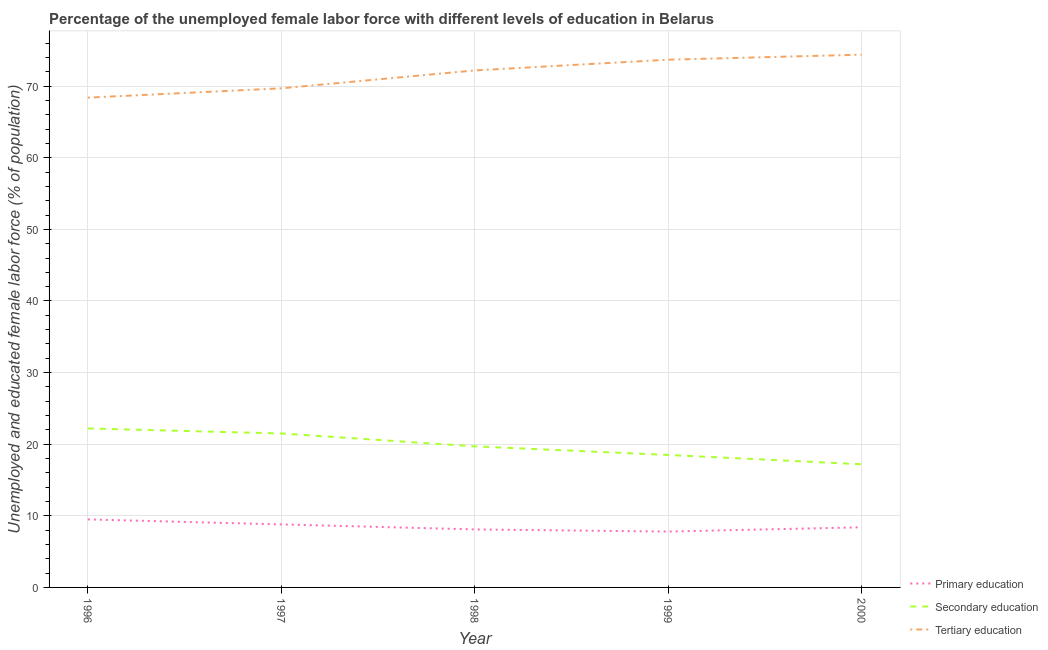Does the line corresponding to percentage of female labor force who received tertiary education intersect with the line corresponding to percentage of female labor force who received secondary education?
Provide a short and direct response. No. Is the number of lines equal to the number of legend labels?
Ensure brevity in your answer.  Yes. What is the percentage of female labor force who received tertiary education in 1999?
Offer a terse response. 73.7. Across all years, what is the maximum percentage of female labor force who received secondary education?
Ensure brevity in your answer.  22.2. Across all years, what is the minimum percentage of female labor force who received secondary education?
Provide a short and direct response. 17.2. What is the total percentage of female labor force who received primary education in the graph?
Provide a short and direct response. 42.6. What is the difference between the percentage of female labor force who received tertiary education in 1996 and that in 2000?
Make the answer very short. -6. What is the difference between the percentage of female labor force who received tertiary education in 1999 and the percentage of female labor force who received secondary education in 1998?
Your answer should be very brief. 54. What is the average percentage of female labor force who received tertiary education per year?
Your answer should be very brief. 71.68. In the year 2000, what is the difference between the percentage of female labor force who received primary education and percentage of female labor force who received tertiary education?
Your response must be concise. -66. What is the ratio of the percentage of female labor force who received secondary education in 1997 to that in 2000?
Keep it short and to the point. 1.25. What is the difference between the highest and the second highest percentage of female labor force who received primary education?
Your answer should be compact. 0.7. What is the difference between the highest and the lowest percentage of female labor force who received tertiary education?
Ensure brevity in your answer.  6. In how many years, is the percentage of female labor force who received tertiary education greater than the average percentage of female labor force who received tertiary education taken over all years?
Give a very brief answer. 3. Is the sum of the percentage of female labor force who received primary education in 1996 and 1999 greater than the maximum percentage of female labor force who received secondary education across all years?
Offer a very short reply. No. Is the percentage of female labor force who received tertiary education strictly greater than the percentage of female labor force who received primary education over the years?
Offer a very short reply. Yes. Does the graph contain grids?
Offer a very short reply. Yes. Where does the legend appear in the graph?
Offer a very short reply. Bottom right. How many legend labels are there?
Your answer should be compact. 3. What is the title of the graph?
Offer a terse response. Percentage of the unemployed female labor force with different levels of education in Belarus. What is the label or title of the X-axis?
Provide a short and direct response. Year. What is the label or title of the Y-axis?
Make the answer very short. Unemployed and educated female labor force (% of population). What is the Unemployed and educated female labor force (% of population) in Secondary education in 1996?
Offer a terse response. 22.2. What is the Unemployed and educated female labor force (% of population) of Tertiary education in 1996?
Your response must be concise. 68.4. What is the Unemployed and educated female labor force (% of population) of Primary education in 1997?
Provide a succinct answer. 8.8. What is the Unemployed and educated female labor force (% of population) of Tertiary education in 1997?
Give a very brief answer. 69.7. What is the Unemployed and educated female labor force (% of population) of Primary education in 1998?
Offer a very short reply. 8.1. What is the Unemployed and educated female labor force (% of population) of Secondary education in 1998?
Offer a very short reply. 19.7. What is the Unemployed and educated female labor force (% of population) of Tertiary education in 1998?
Your answer should be very brief. 72.2. What is the Unemployed and educated female labor force (% of population) in Primary education in 1999?
Offer a terse response. 7.8. What is the Unemployed and educated female labor force (% of population) in Secondary education in 1999?
Make the answer very short. 18.5. What is the Unemployed and educated female labor force (% of population) of Tertiary education in 1999?
Provide a short and direct response. 73.7. What is the Unemployed and educated female labor force (% of population) in Primary education in 2000?
Give a very brief answer. 8.4. What is the Unemployed and educated female labor force (% of population) in Secondary education in 2000?
Ensure brevity in your answer.  17.2. What is the Unemployed and educated female labor force (% of population) in Tertiary education in 2000?
Provide a short and direct response. 74.4. Across all years, what is the maximum Unemployed and educated female labor force (% of population) of Primary education?
Make the answer very short. 9.5. Across all years, what is the maximum Unemployed and educated female labor force (% of population) of Secondary education?
Ensure brevity in your answer.  22.2. Across all years, what is the maximum Unemployed and educated female labor force (% of population) in Tertiary education?
Your answer should be compact. 74.4. Across all years, what is the minimum Unemployed and educated female labor force (% of population) in Primary education?
Offer a terse response. 7.8. Across all years, what is the minimum Unemployed and educated female labor force (% of population) in Secondary education?
Your answer should be compact. 17.2. Across all years, what is the minimum Unemployed and educated female labor force (% of population) in Tertiary education?
Give a very brief answer. 68.4. What is the total Unemployed and educated female labor force (% of population) in Primary education in the graph?
Provide a succinct answer. 42.6. What is the total Unemployed and educated female labor force (% of population) of Secondary education in the graph?
Ensure brevity in your answer.  99.1. What is the total Unemployed and educated female labor force (% of population) of Tertiary education in the graph?
Provide a succinct answer. 358.4. What is the difference between the Unemployed and educated female labor force (% of population) in Secondary education in 1996 and that in 1997?
Keep it short and to the point. 0.7. What is the difference between the Unemployed and educated female labor force (% of population) in Secondary education in 1996 and that in 1998?
Offer a terse response. 2.5. What is the difference between the Unemployed and educated female labor force (% of population) in Tertiary education in 1996 and that in 1998?
Give a very brief answer. -3.8. What is the difference between the Unemployed and educated female labor force (% of population) in Primary education in 1996 and that in 2000?
Keep it short and to the point. 1.1. What is the difference between the Unemployed and educated female labor force (% of population) of Tertiary education in 1996 and that in 2000?
Make the answer very short. -6. What is the difference between the Unemployed and educated female labor force (% of population) in Primary education in 1997 and that in 1998?
Give a very brief answer. 0.7. What is the difference between the Unemployed and educated female labor force (% of population) of Tertiary education in 1998 and that in 2000?
Your answer should be compact. -2.2. What is the difference between the Unemployed and educated female labor force (% of population) of Secondary education in 1999 and that in 2000?
Keep it short and to the point. 1.3. What is the difference between the Unemployed and educated female labor force (% of population) of Primary education in 1996 and the Unemployed and educated female labor force (% of population) of Secondary education in 1997?
Offer a terse response. -12. What is the difference between the Unemployed and educated female labor force (% of population) of Primary education in 1996 and the Unemployed and educated female labor force (% of population) of Tertiary education in 1997?
Your answer should be compact. -60.2. What is the difference between the Unemployed and educated female labor force (% of population) of Secondary education in 1996 and the Unemployed and educated female labor force (% of population) of Tertiary education in 1997?
Ensure brevity in your answer.  -47.5. What is the difference between the Unemployed and educated female labor force (% of population) of Primary education in 1996 and the Unemployed and educated female labor force (% of population) of Secondary education in 1998?
Give a very brief answer. -10.2. What is the difference between the Unemployed and educated female labor force (% of population) in Primary education in 1996 and the Unemployed and educated female labor force (% of population) in Tertiary education in 1998?
Make the answer very short. -62.7. What is the difference between the Unemployed and educated female labor force (% of population) of Primary education in 1996 and the Unemployed and educated female labor force (% of population) of Tertiary education in 1999?
Ensure brevity in your answer.  -64.2. What is the difference between the Unemployed and educated female labor force (% of population) of Secondary education in 1996 and the Unemployed and educated female labor force (% of population) of Tertiary education in 1999?
Provide a short and direct response. -51.5. What is the difference between the Unemployed and educated female labor force (% of population) of Primary education in 1996 and the Unemployed and educated female labor force (% of population) of Secondary education in 2000?
Your answer should be compact. -7.7. What is the difference between the Unemployed and educated female labor force (% of population) of Primary education in 1996 and the Unemployed and educated female labor force (% of population) of Tertiary education in 2000?
Your answer should be compact. -64.9. What is the difference between the Unemployed and educated female labor force (% of population) in Secondary education in 1996 and the Unemployed and educated female labor force (% of population) in Tertiary education in 2000?
Offer a terse response. -52.2. What is the difference between the Unemployed and educated female labor force (% of population) in Primary education in 1997 and the Unemployed and educated female labor force (% of population) in Secondary education in 1998?
Your response must be concise. -10.9. What is the difference between the Unemployed and educated female labor force (% of population) in Primary education in 1997 and the Unemployed and educated female labor force (% of population) in Tertiary education in 1998?
Your answer should be very brief. -63.4. What is the difference between the Unemployed and educated female labor force (% of population) of Secondary education in 1997 and the Unemployed and educated female labor force (% of population) of Tertiary education in 1998?
Make the answer very short. -50.7. What is the difference between the Unemployed and educated female labor force (% of population) in Primary education in 1997 and the Unemployed and educated female labor force (% of population) in Tertiary education in 1999?
Provide a succinct answer. -64.9. What is the difference between the Unemployed and educated female labor force (% of population) in Secondary education in 1997 and the Unemployed and educated female labor force (% of population) in Tertiary education in 1999?
Your response must be concise. -52.2. What is the difference between the Unemployed and educated female labor force (% of population) of Primary education in 1997 and the Unemployed and educated female labor force (% of population) of Secondary education in 2000?
Give a very brief answer. -8.4. What is the difference between the Unemployed and educated female labor force (% of population) in Primary education in 1997 and the Unemployed and educated female labor force (% of population) in Tertiary education in 2000?
Ensure brevity in your answer.  -65.6. What is the difference between the Unemployed and educated female labor force (% of population) of Secondary education in 1997 and the Unemployed and educated female labor force (% of population) of Tertiary education in 2000?
Offer a terse response. -52.9. What is the difference between the Unemployed and educated female labor force (% of population) of Primary education in 1998 and the Unemployed and educated female labor force (% of population) of Tertiary education in 1999?
Your answer should be very brief. -65.6. What is the difference between the Unemployed and educated female labor force (% of population) in Secondary education in 1998 and the Unemployed and educated female labor force (% of population) in Tertiary education in 1999?
Offer a terse response. -54. What is the difference between the Unemployed and educated female labor force (% of population) of Primary education in 1998 and the Unemployed and educated female labor force (% of population) of Secondary education in 2000?
Your response must be concise. -9.1. What is the difference between the Unemployed and educated female labor force (% of population) in Primary education in 1998 and the Unemployed and educated female labor force (% of population) in Tertiary education in 2000?
Your response must be concise. -66.3. What is the difference between the Unemployed and educated female labor force (% of population) in Secondary education in 1998 and the Unemployed and educated female labor force (% of population) in Tertiary education in 2000?
Offer a terse response. -54.7. What is the difference between the Unemployed and educated female labor force (% of population) in Primary education in 1999 and the Unemployed and educated female labor force (% of population) in Secondary education in 2000?
Your response must be concise. -9.4. What is the difference between the Unemployed and educated female labor force (% of population) in Primary education in 1999 and the Unemployed and educated female labor force (% of population) in Tertiary education in 2000?
Make the answer very short. -66.6. What is the difference between the Unemployed and educated female labor force (% of population) of Secondary education in 1999 and the Unemployed and educated female labor force (% of population) of Tertiary education in 2000?
Provide a succinct answer. -55.9. What is the average Unemployed and educated female labor force (% of population) in Primary education per year?
Your answer should be compact. 8.52. What is the average Unemployed and educated female labor force (% of population) of Secondary education per year?
Make the answer very short. 19.82. What is the average Unemployed and educated female labor force (% of population) of Tertiary education per year?
Give a very brief answer. 71.68. In the year 1996, what is the difference between the Unemployed and educated female labor force (% of population) of Primary education and Unemployed and educated female labor force (% of population) of Secondary education?
Provide a short and direct response. -12.7. In the year 1996, what is the difference between the Unemployed and educated female labor force (% of population) of Primary education and Unemployed and educated female labor force (% of population) of Tertiary education?
Your response must be concise. -58.9. In the year 1996, what is the difference between the Unemployed and educated female labor force (% of population) in Secondary education and Unemployed and educated female labor force (% of population) in Tertiary education?
Keep it short and to the point. -46.2. In the year 1997, what is the difference between the Unemployed and educated female labor force (% of population) in Primary education and Unemployed and educated female labor force (% of population) in Secondary education?
Provide a short and direct response. -12.7. In the year 1997, what is the difference between the Unemployed and educated female labor force (% of population) of Primary education and Unemployed and educated female labor force (% of population) of Tertiary education?
Your response must be concise. -60.9. In the year 1997, what is the difference between the Unemployed and educated female labor force (% of population) in Secondary education and Unemployed and educated female labor force (% of population) in Tertiary education?
Make the answer very short. -48.2. In the year 1998, what is the difference between the Unemployed and educated female labor force (% of population) of Primary education and Unemployed and educated female labor force (% of population) of Tertiary education?
Give a very brief answer. -64.1. In the year 1998, what is the difference between the Unemployed and educated female labor force (% of population) of Secondary education and Unemployed and educated female labor force (% of population) of Tertiary education?
Provide a succinct answer. -52.5. In the year 1999, what is the difference between the Unemployed and educated female labor force (% of population) in Primary education and Unemployed and educated female labor force (% of population) in Tertiary education?
Your answer should be very brief. -65.9. In the year 1999, what is the difference between the Unemployed and educated female labor force (% of population) of Secondary education and Unemployed and educated female labor force (% of population) of Tertiary education?
Your answer should be very brief. -55.2. In the year 2000, what is the difference between the Unemployed and educated female labor force (% of population) in Primary education and Unemployed and educated female labor force (% of population) in Secondary education?
Your answer should be compact. -8.8. In the year 2000, what is the difference between the Unemployed and educated female labor force (% of population) in Primary education and Unemployed and educated female labor force (% of population) in Tertiary education?
Give a very brief answer. -66. In the year 2000, what is the difference between the Unemployed and educated female labor force (% of population) in Secondary education and Unemployed and educated female labor force (% of population) in Tertiary education?
Provide a short and direct response. -57.2. What is the ratio of the Unemployed and educated female labor force (% of population) in Primary education in 1996 to that in 1997?
Make the answer very short. 1.08. What is the ratio of the Unemployed and educated female labor force (% of population) in Secondary education in 1996 to that in 1997?
Keep it short and to the point. 1.03. What is the ratio of the Unemployed and educated female labor force (% of population) of Tertiary education in 1996 to that in 1997?
Ensure brevity in your answer.  0.98. What is the ratio of the Unemployed and educated female labor force (% of population) in Primary education in 1996 to that in 1998?
Your answer should be very brief. 1.17. What is the ratio of the Unemployed and educated female labor force (% of population) of Secondary education in 1996 to that in 1998?
Offer a terse response. 1.13. What is the ratio of the Unemployed and educated female labor force (% of population) in Primary education in 1996 to that in 1999?
Your answer should be compact. 1.22. What is the ratio of the Unemployed and educated female labor force (% of population) of Secondary education in 1996 to that in 1999?
Offer a very short reply. 1.2. What is the ratio of the Unemployed and educated female labor force (% of population) in Tertiary education in 1996 to that in 1999?
Ensure brevity in your answer.  0.93. What is the ratio of the Unemployed and educated female labor force (% of population) of Primary education in 1996 to that in 2000?
Offer a very short reply. 1.13. What is the ratio of the Unemployed and educated female labor force (% of population) of Secondary education in 1996 to that in 2000?
Make the answer very short. 1.29. What is the ratio of the Unemployed and educated female labor force (% of population) of Tertiary education in 1996 to that in 2000?
Your answer should be compact. 0.92. What is the ratio of the Unemployed and educated female labor force (% of population) of Primary education in 1997 to that in 1998?
Keep it short and to the point. 1.09. What is the ratio of the Unemployed and educated female labor force (% of population) of Secondary education in 1997 to that in 1998?
Provide a succinct answer. 1.09. What is the ratio of the Unemployed and educated female labor force (% of population) in Tertiary education in 1997 to that in 1998?
Offer a terse response. 0.97. What is the ratio of the Unemployed and educated female labor force (% of population) in Primary education in 1997 to that in 1999?
Provide a short and direct response. 1.13. What is the ratio of the Unemployed and educated female labor force (% of population) in Secondary education in 1997 to that in 1999?
Give a very brief answer. 1.16. What is the ratio of the Unemployed and educated female labor force (% of population) in Tertiary education in 1997 to that in 1999?
Provide a succinct answer. 0.95. What is the ratio of the Unemployed and educated female labor force (% of population) of Primary education in 1997 to that in 2000?
Your answer should be very brief. 1.05. What is the ratio of the Unemployed and educated female labor force (% of population) of Secondary education in 1997 to that in 2000?
Provide a succinct answer. 1.25. What is the ratio of the Unemployed and educated female labor force (% of population) of Tertiary education in 1997 to that in 2000?
Give a very brief answer. 0.94. What is the ratio of the Unemployed and educated female labor force (% of population) of Primary education in 1998 to that in 1999?
Keep it short and to the point. 1.04. What is the ratio of the Unemployed and educated female labor force (% of population) of Secondary education in 1998 to that in 1999?
Your response must be concise. 1.06. What is the ratio of the Unemployed and educated female labor force (% of population) of Tertiary education in 1998 to that in 1999?
Provide a succinct answer. 0.98. What is the ratio of the Unemployed and educated female labor force (% of population) in Secondary education in 1998 to that in 2000?
Make the answer very short. 1.15. What is the ratio of the Unemployed and educated female labor force (% of population) of Tertiary education in 1998 to that in 2000?
Keep it short and to the point. 0.97. What is the ratio of the Unemployed and educated female labor force (% of population) of Primary education in 1999 to that in 2000?
Provide a succinct answer. 0.93. What is the ratio of the Unemployed and educated female labor force (% of population) of Secondary education in 1999 to that in 2000?
Your answer should be compact. 1.08. What is the ratio of the Unemployed and educated female labor force (% of population) of Tertiary education in 1999 to that in 2000?
Offer a terse response. 0.99. What is the difference between the highest and the second highest Unemployed and educated female labor force (% of population) of Secondary education?
Your response must be concise. 0.7. What is the difference between the highest and the lowest Unemployed and educated female labor force (% of population) of Primary education?
Your answer should be compact. 1.7. What is the difference between the highest and the lowest Unemployed and educated female labor force (% of population) of Secondary education?
Provide a short and direct response. 5. 